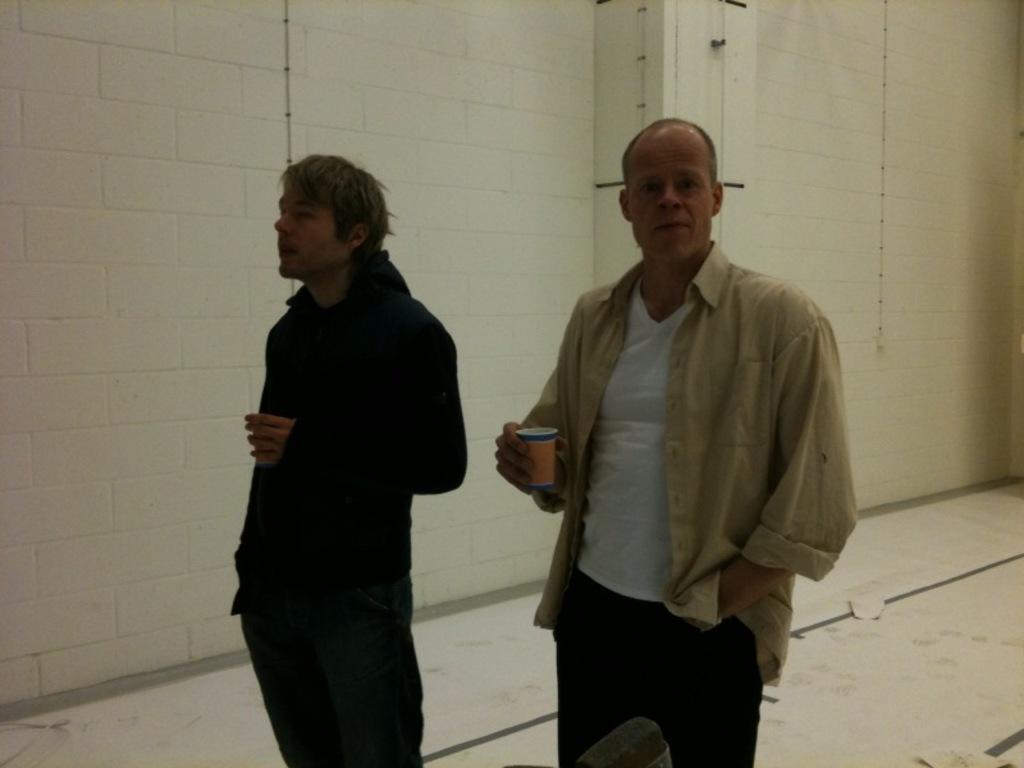Who or what is present in the image? There are people in the image. What are the people holding in their hands? The people are holding cups. What can be seen behind the people in the image? There is a wall in the background of the image. What is the surface on which the people are standing? There is a floor at the bottom of the image. Can you see any feathers floating in the ocean in the image? There is no ocean or feathers present in the image. 